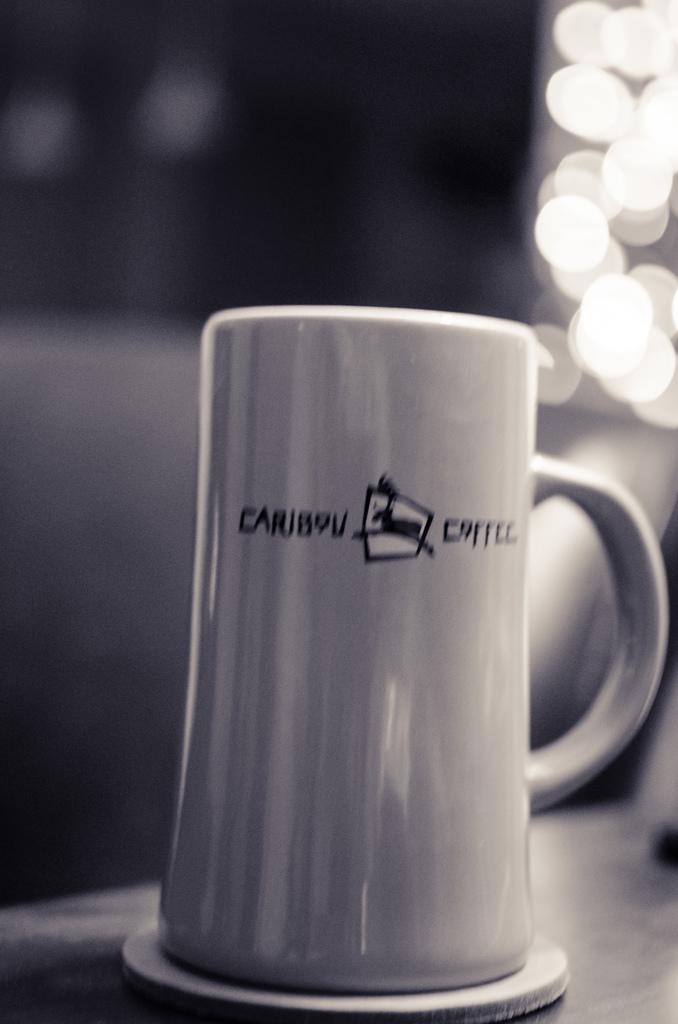<image>
Render a clear and concise summary of the photo. A mug has the name Caribou Coffee on it. 